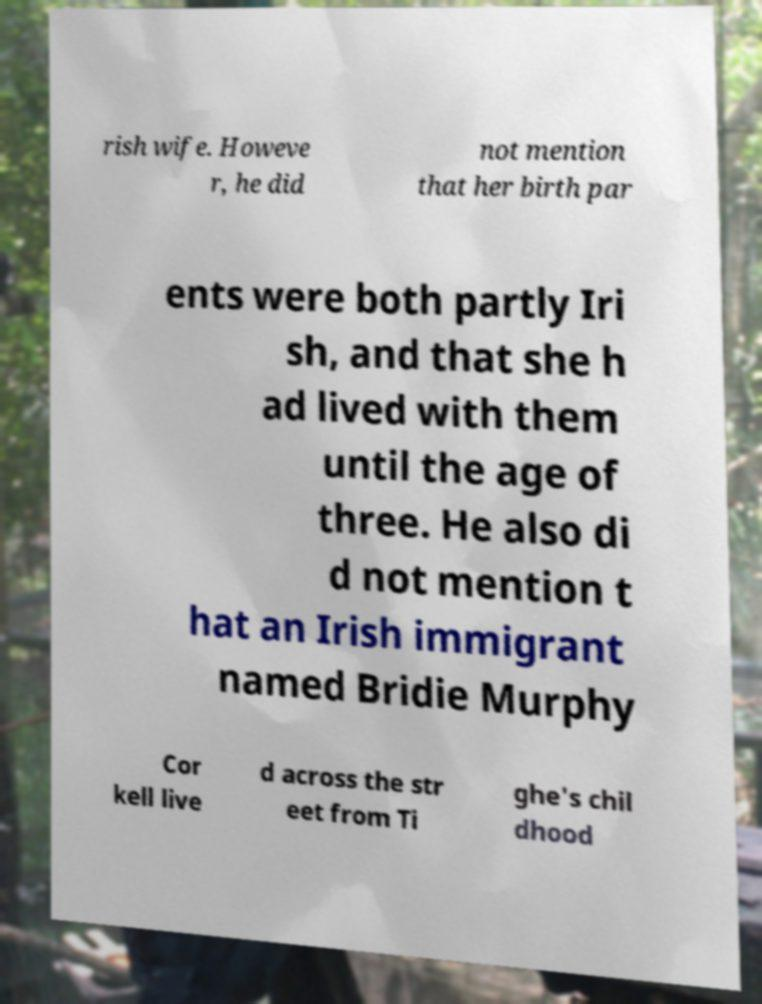Please read and relay the text visible in this image. What does it say? rish wife. Howeve r, he did not mention that her birth par ents were both partly Iri sh, and that she h ad lived with them until the age of three. He also di d not mention t hat an Irish immigrant named Bridie Murphy Cor kell live d across the str eet from Ti ghe's chil dhood 